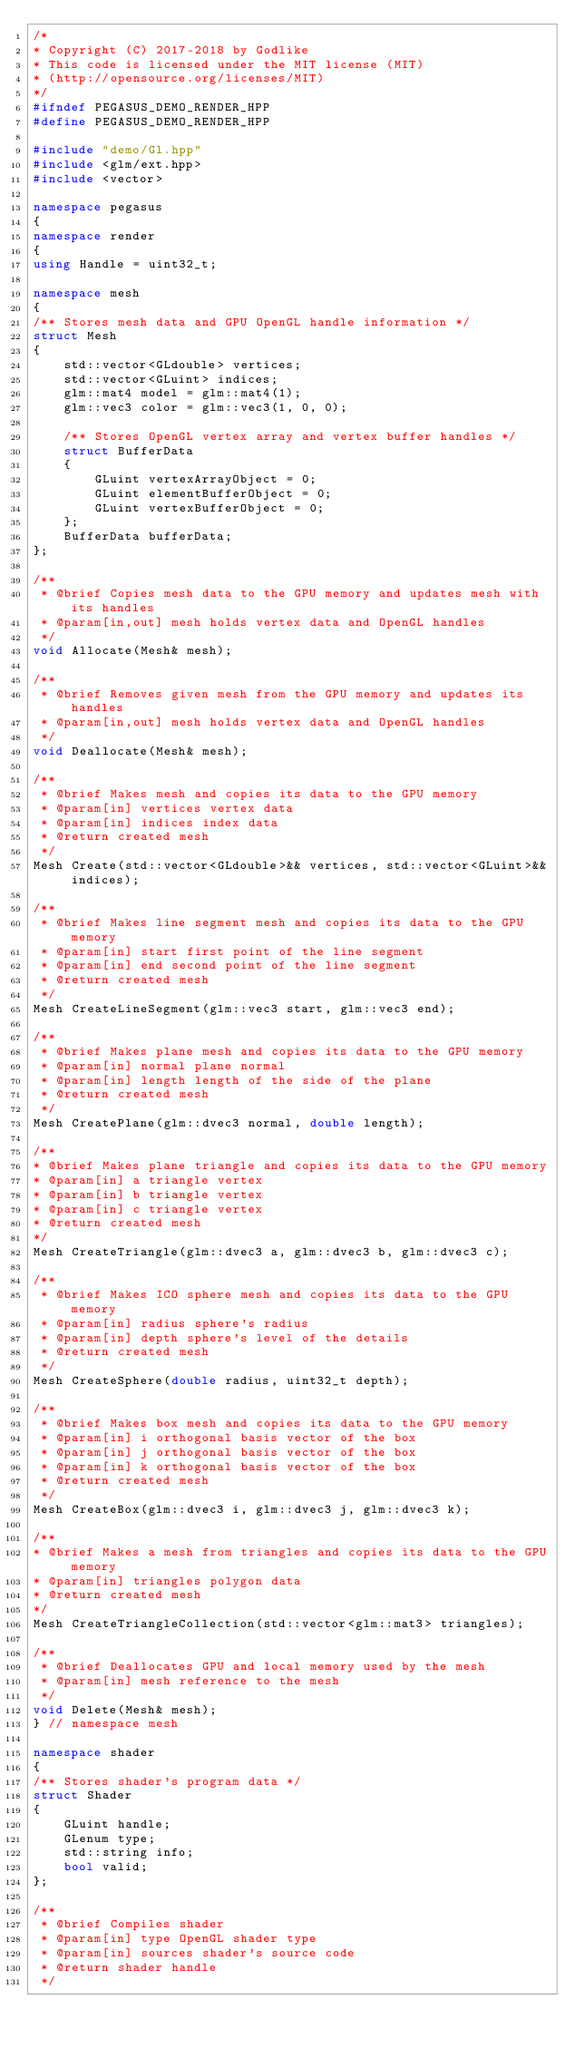<code> <loc_0><loc_0><loc_500><loc_500><_C++_>/*
* Copyright (C) 2017-2018 by Godlike
* This code is licensed under the MIT license (MIT)
* (http://opensource.org/licenses/MIT)
*/
#ifndef PEGASUS_DEMO_RENDER_HPP
#define PEGASUS_DEMO_RENDER_HPP

#include "demo/Gl.hpp"
#include <glm/ext.hpp>
#include <vector>

namespace pegasus
{
namespace render
{
using Handle = uint32_t;

namespace mesh
{
/** Stores mesh data and GPU OpenGL handle information */
struct Mesh
{
    std::vector<GLdouble> vertices;
    std::vector<GLuint> indices;
    glm::mat4 model = glm::mat4(1);
    glm::vec3 color = glm::vec3(1, 0, 0);

    /** Stores OpenGL vertex array and vertex buffer handles */
    struct BufferData
    {
        GLuint vertexArrayObject = 0;
        GLuint elementBufferObject = 0;
        GLuint vertexBufferObject = 0;
    };
    BufferData bufferData;
};

/**
 * @brief Copies mesh data to the GPU memory and updates mesh with its handles
 * @param[in,out] mesh holds vertex data and OpenGL handles
 */
void Allocate(Mesh& mesh);

/**
 * @brief Removes given mesh from the GPU memory and updates its handles
 * @param[in,out] mesh holds vertex data and OpenGL handles
 */
void Deallocate(Mesh& mesh);

/**
 * @brief Makes mesh and copies its data to the GPU memory
 * @param[in] vertices vertex data
 * @param[in] indices index data
 * @return created mesh
 */
Mesh Create(std::vector<GLdouble>&& vertices, std::vector<GLuint>&& indices);

/**
 * @brief Makes line segment mesh and copies its data to the GPU memory
 * @param[in] start first point of the line segment
 * @param[in] end second point of the line segment
 * @return created mesh
 */
Mesh CreateLineSegment(glm::vec3 start, glm::vec3 end);

/**
 * @brief Makes plane mesh and copies its data to the GPU memory
 * @param[in] normal plane normal
 * @param[in] length length of the side of the plane
 * @return created mesh
 */
Mesh CreatePlane(glm::dvec3 normal, double length);

/**
* @brief Makes plane triangle and copies its data to the GPU memory
* @param[in] a triangle vertex
* @param[in] b triangle vertex
* @param[in] c triangle vertex
* @return created mesh
*/
Mesh CreateTriangle(glm::dvec3 a, glm::dvec3 b, glm::dvec3 c);

/**
 * @brief Makes ICO sphere mesh and copies its data to the GPU memory
 * @param[in] radius sphere's radius
 * @param[in] depth sphere's level of the details
 * @return created mesh
 */
Mesh CreateSphere(double radius, uint32_t depth);

/**
 * @brief Makes box mesh and copies its data to the GPU memory
 * @param[in] i orthogonal basis vector of the box
 * @param[in] j orthogonal basis vector of the box
 * @param[in] k orthogonal basis vector of the box
 * @return created mesh
 */
Mesh CreateBox(glm::dvec3 i, glm::dvec3 j, glm::dvec3 k);

/**
* @brief Makes a mesh from triangles and copies its data to the GPU memory
* @param[in] triangles polygon data
* @return created mesh
*/
Mesh CreateTriangleCollection(std::vector<glm::mat3> triangles);

/**
 * @brief Deallocates GPU and local memory used by the mesh
 * @param[in] mesh reference to the mesh
 */
void Delete(Mesh& mesh);
} // namespace mesh

namespace shader
{
/** Stores shader's program data */
struct Shader
{
    GLuint handle;
    GLenum type;
    std::string info;
    bool valid;
};

/**
 * @brief Compiles shader
 * @param[in] type OpenGL shader type
 * @param[in] sources shader's source code
 * @return shader handle
 */</code> 